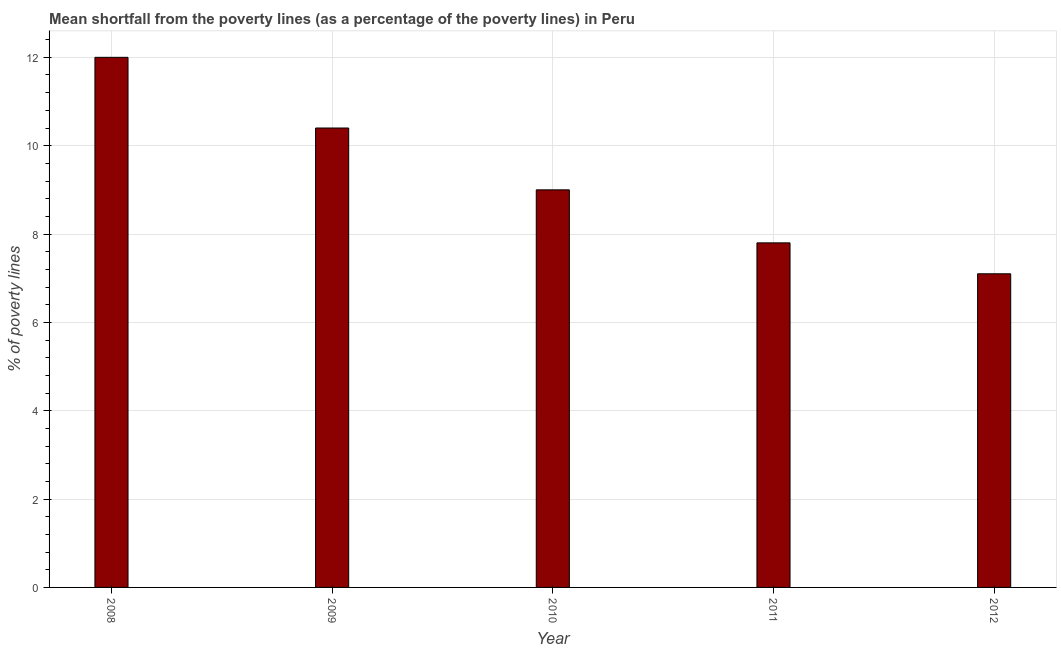Does the graph contain grids?
Your answer should be very brief. Yes. What is the title of the graph?
Offer a terse response. Mean shortfall from the poverty lines (as a percentage of the poverty lines) in Peru. What is the label or title of the Y-axis?
Your answer should be very brief. % of poverty lines. Across all years, what is the maximum poverty gap at national poverty lines?
Provide a succinct answer. 12. What is the sum of the poverty gap at national poverty lines?
Provide a short and direct response. 46.3. What is the average poverty gap at national poverty lines per year?
Offer a terse response. 9.26. What is the ratio of the poverty gap at national poverty lines in 2008 to that in 2010?
Provide a short and direct response. 1.33. Is the poverty gap at national poverty lines in 2011 less than that in 2012?
Your answer should be compact. No. Is the difference between the poverty gap at national poverty lines in 2009 and 2012 greater than the difference between any two years?
Provide a short and direct response. No. What is the difference between the highest and the second highest poverty gap at national poverty lines?
Give a very brief answer. 1.6. What is the difference between the highest and the lowest poverty gap at national poverty lines?
Make the answer very short. 4.9. In how many years, is the poverty gap at national poverty lines greater than the average poverty gap at national poverty lines taken over all years?
Keep it short and to the point. 2. Are all the bars in the graph horizontal?
Provide a succinct answer. No. How many years are there in the graph?
Your answer should be compact. 5. What is the % of poverty lines of 2008?
Provide a short and direct response. 12. What is the % of poverty lines of 2010?
Your answer should be compact. 9. What is the % of poverty lines in 2011?
Your answer should be very brief. 7.8. What is the difference between the % of poverty lines in 2008 and 2012?
Your answer should be very brief. 4.9. What is the difference between the % of poverty lines in 2009 and 2010?
Make the answer very short. 1.4. What is the difference between the % of poverty lines in 2009 and 2011?
Your answer should be very brief. 2.6. What is the difference between the % of poverty lines in 2009 and 2012?
Your response must be concise. 3.3. What is the difference between the % of poverty lines in 2011 and 2012?
Provide a short and direct response. 0.7. What is the ratio of the % of poverty lines in 2008 to that in 2009?
Your answer should be very brief. 1.15. What is the ratio of the % of poverty lines in 2008 to that in 2010?
Your answer should be very brief. 1.33. What is the ratio of the % of poverty lines in 2008 to that in 2011?
Your response must be concise. 1.54. What is the ratio of the % of poverty lines in 2008 to that in 2012?
Offer a terse response. 1.69. What is the ratio of the % of poverty lines in 2009 to that in 2010?
Offer a terse response. 1.16. What is the ratio of the % of poverty lines in 2009 to that in 2011?
Provide a succinct answer. 1.33. What is the ratio of the % of poverty lines in 2009 to that in 2012?
Provide a short and direct response. 1.47. What is the ratio of the % of poverty lines in 2010 to that in 2011?
Offer a terse response. 1.15. What is the ratio of the % of poverty lines in 2010 to that in 2012?
Make the answer very short. 1.27. What is the ratio of the % of poverty lines in 2011 to that in 2012?
Your answer should be compact. 1.1. 